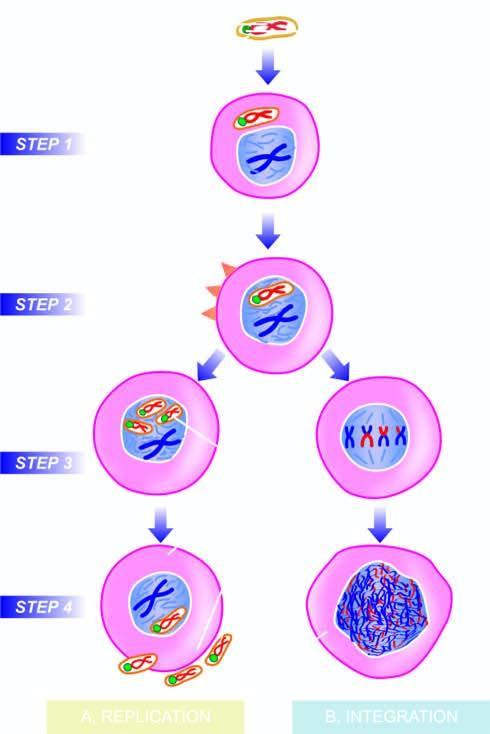does the sectioned surface invade the host cell?
Answer the question using a single word or phrase. No 